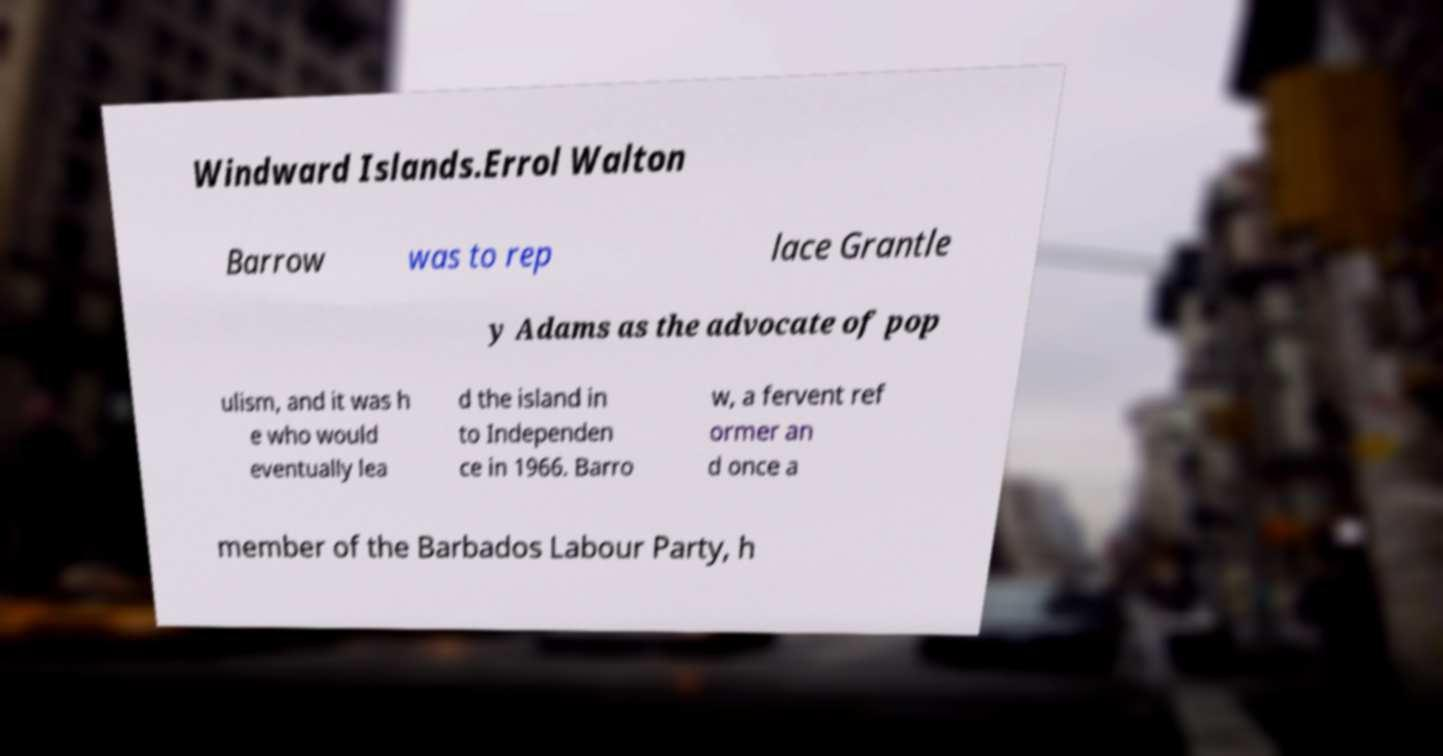Can you accurately transcribe the text from the provided image for me? Windward Islands.Errol Walton Barrow was to rep lace Grantle y Adams as the advocate of pop ulism, and it was h e who would eventually lea d the island in to Independen ce in 1966. Barro w, a fervent ref ormer an d once a member of the Barbados Labour Party, h 